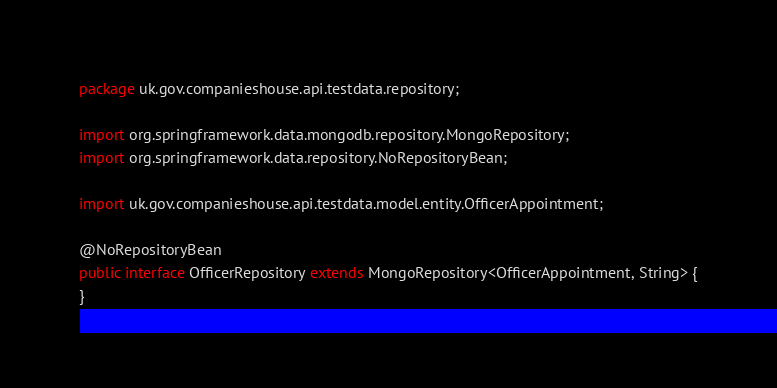Convert code to text. <code><loc_0><loc_0><loc_500><loc_500><_Java_>package uk.gov.companieshouse.api.testdata.repository;

import org.springframework.data.mongodb.repository.MongoRepository;
import org.springframework.data.repository.NoRepositoryBean;

import uk.gov.companieshouse.api.testdata.model.entity.OfficerAppointment;

@NoRepositoryBean
public interface OfficerRepository extends MongoRepository<OfficerAppointment, String> {
}
</code> 